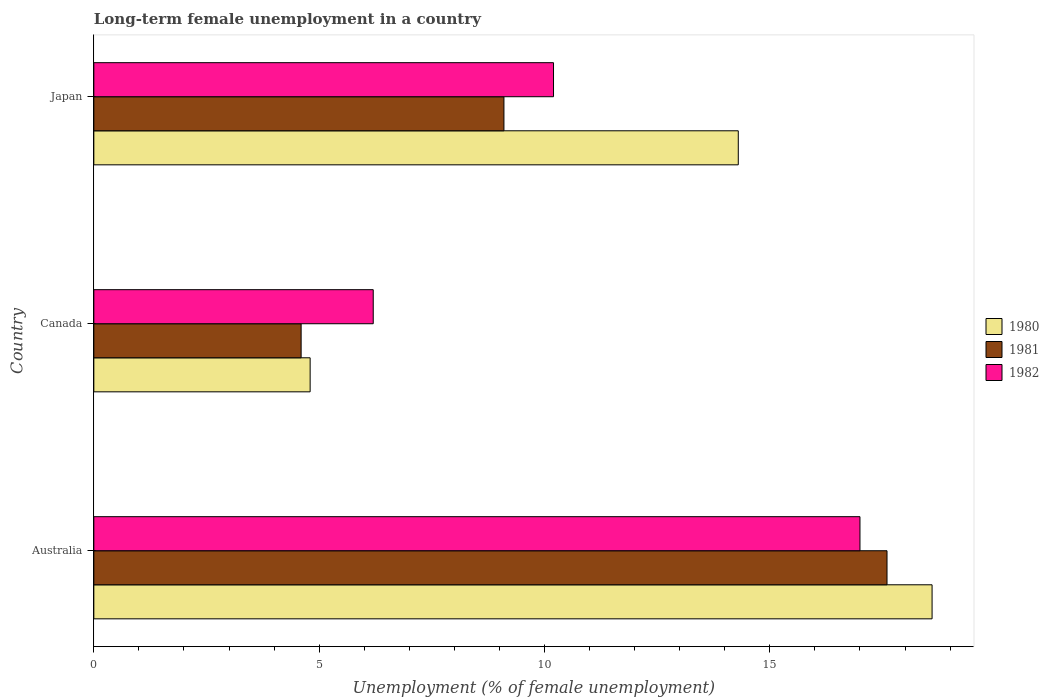How many different coloured bars are there?
Keep it short and to the point. 3. Are the number of bars on each tick of the Y-axis equal?
Give a very brief answer. Yes. How many bars are there on the 2nd tick from the top?
Give a very brief answer. 3. What is the label of the 1st group of bars from the top?
Keep it short and to the point. Japan. In how many cases, is the number of bars for a given country not equal to the number of legend labels?
Keep it short and to the point. 0. What is the percentage of long-term unemployed female population in 1980 in Canada?
Offer a terse response. 4.8. Across all countries, what is the minimum percentage of long-term unemployed female population in 1982?
Ensure brevity in your answer.  6.2. What is the total percentage of long-term unemployed female population in 1980 in the graph?
Offer a terse response. 37.7. What is the difference between the percentage of long-term unemployed female population in 1982 in Australia and that in Japan?
Your answer should be compact. 6.8. What is the difference between the percentage of long-term unemployed female population in 1980 in Japan and the percentage of long-term unemployed female population in 1981 in Australia?
Ensure brevity in your answer.  -3.3. What is the average percentage of long-term unemployed female population in 1982 per country?
Offer a very short reply. 11.13. What is the difference between the percentage of long-term unemployed female population in 1982 and percentage of long-term unemployed female population in 1980 in Japan?
Provide a short and direct response. -4.1. In how many countries, is the percentage of long-term unemployed female population in 1982 greater than 10 %?
Offer a terse response. 2. What is the ratio of the percentage of long-term unemployed female population in 1981 in Canada to that in Japan?
Provide a short and direct response. 0.51. Is the percentage of long-term unemployed female population in 1981 in Canada less than that in Japan?
Ensure brevity in your answer.  Yes. Is the difference between the percentage of long-term unemployed female population in 1982 in Canada and Japan greater than the difference between the percentage of long-term unemployed female population in 1980 in Canada and Japan?
Keep it short and to the point. Yes. What is the difference between the highest and the second highest percentage of long-term unemployed female population in 1980?
Provide a short and direct response. 4.3. What is the difference between the highest and the lowest percentage of long-term unemployed female population in 1981?
Make the answer very short. 13. What does the 2nd bar from the top in Australia represents?
Offer a very short reply. 1981. How many countries are there in the graph?
Make the answer very short. 3. Does the graph contain any zero values?
Ensure brevity in your answer.  No. How are the legend labels stacked?
Make the answer very short. Vertical. What is the title of the graph?
Make the answer very short. Long-term female unemployment in a country. What is the label or title of the X-axis?
Your answer should be compact. Unemployment (% of female unemployment). What is the Unemployment (% of female unemployment) in 1980 in Australia?
Give a very brief answer. 18.6. What is the Unemployment (% of female unemployment) of 1981 in Australia?
Keep it short and to the point. 17.6. What is the Unemployment (% of female unemployment) of 1980 in Canada?
Your response must be concise. 4.8. What is the Unemployment (% of female unemployment) in 1981 in Canada?
Give a very brief answer. 4.6. What is the Unemployment (% of female unemployment) of 1982 in Canada?
Keep it short and to the point. 6.2. What is the Unemployment (% of female unemployment) of 1980 in Japan?
Offer a very short reply. 14.3. What is the Unemployment (% of female unemployment) of 1981 in Japan?
Make the answer very short. 9.1. What is the Unemployment (% of female unemployment) in 1982 in Japan?
Offer a very short reply. 10.2. Across all countries, what is the maximum Unemployment (% of female unemployment) in 1980?
Keep it short and to the point. 18.6. Across all countries, what is the maximum Unemployment (% of female unemployment) of 1981?
Give a very brief answer. 17.6. Across all countries, what is the maximum Unemployment (% of female unemployment) of 1982?
Provide a succinct answer. 17. Across all countries, what is the minimum Unemployment (% of female unemployment) of 1980?
Give a very brief answer. 4.8. Across all countries, what is the minimum Unemployment (% of female unemployment) in 1981?
Your answer should be very brief. 4.6. Across all countries, what is the minimum Unemployment (% of female unemployment) of 1982?
Keep it short and to the point. 6.2. What is the total Unemployment (% of female unemployment) in 1980 in the graph?
Give a very brief answer. 37.7. What is the total Unemployment (% of female unemployment) in 1981 in the graph?
Provide a succinct answer. 31.3. What is the total Unemployment (% of female unemployment) of 1982 in the graph?
Keep it short and to the point. 33.4. What is the difference between the Unemployment (% of female unemployment) in 1982 in Australia and that in Canada?
Provide a short and direct response. 10.8. What is the difference between the Unemployment (% of female unemployment) of 1980 in Australia and that in Japan?
Keep it short and to the point. 4.3. What is the difference between the Unemployment (% of female unemployment) of 1981 in Australia and that in Japan?
Provide a succinct answer. 8.5. What is the difference between the Unemployment (% of female unemployment) in 1982 in Australia and that in Japan?
Offer a terse response. 6.8. What is the difference between the Unemployment (% of female unemployment) of 1981 in Canada and that in Japan?
Offer a terse response. -4.5. What is the difference between the Unemployment (% of female unemployment) of 1982 in Canada and that in Japan?
Ensure brevity in your answer.  -4. What is the difference between the Unemployment (% of female unemployment) of 1980 in Australia and the Unemployment (% of female unemployment) of 1981 in Canada?
Your answer should be very brief. 14. What is the difference between the Unemployment (% of female unemployment) in 1981 in Australia and the Unemployment (% of female unemployment) in 1982 in Japan?
Ensure brevity in your answer.  7.4. What is the difference between the Unemployment (% of female unemployment) of 1980 in Canada and the Unemployment (% of female unemployment) of 1981 in Japan?
Your answer should be compact. -4.3. What is the difference between the Unemployment (% of female unemployment) of 1980 in Canada and the Unemployment (% of female unemployment) of 1982 in Japan?
Your answer should be very brief. -5.4. What is the average Unemployment (% of female unemployment) of 1980 per country?
Provide a short and direct response. 12.57. What is the average Unemployment (% of female unemployment) in 1981 per country?
Ensure brevity in your answer.  10.43. What is the average Unemployment (% of female unemployment) in 1982 per country?
Your response must be concise. 11.13. What is the difference between the Unemployment (% of female unemployment) of 1980 and Unemployment (% of female unemployment) of 1981 in Australia?
Keep it short and to the point. 1. What is the difference between the Unemployment (% of female unemployment) of 1981 and Unemployment (% of female unemployment) of 1982 in Canada?
Provide a succinct answer. -1.6. What is the difference between the Unemployment (% of female unemployment) of 1980 and Unemployment (% of female unemployment) of 1981 in Japan?
Give a very brief answer. 5.2. What is the ratio of the Unemployment (% of female unemployment) in 1980 in Australia to that in Canada?
Make the answer very short. 3.88. What is the ratio of the Unemployment (% of female unemployment) in 1981 in Australia to that in Canada?
Keep it short and to the point. 3.83. What is the ratio of the Unemployment (% of female unemployment) of 1982 in Australia to that in Canada?
Provide a short and direct response. 2.74. What is the ratio of the Unemployment (% of female unemployment) of 1980 in Australia to that in Japan?
Provide a short and direct response. 1.3. What is the ratio of the Unemployment (% of female unemployment) in 1981 in Australia to that in Japan?
Your answer should be very brief. 1.93. What is the ratio of the Unemployment (% of female unemployment) in 1982 in Australia to that in Japan?
Keep it short and to the point. 1.67. What is the ratio of the Unemployment (% of female unemployment) of 1980 in Canada to that in Japan?
Keep it short and to the point. 0.34. What is the ratio of the Unemployment (% of female unemployment) in 1981 in Canada to that in Japan?
Your response must be concise. 0.51. What is the ratio of the Unemployment (% of female unemployment) in 1982 in Canada to that in Japan?
Offer a very short reply. 0.61. What is the difference between the highest and the second highest Unemployment (% of female unemployment) in 1980?
Make the answer very short. 4.3. What is the difference between the highest and the second highest Unemployment (% of female unemployment) of 1981?
Provide a succinct answer. 8.5. What is the difference between the highest and the lowest Unemployment (% of female unemployment) of 1982?
Ensure brevity in your answer.  10.8. 